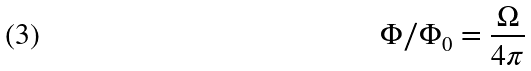Convert formula to latex. <formula><loc_0><loc_0><loc_500><loc_500>\Phi / \Phi _ { 0 } = \frac { \Omega } { 4 \pi }</formula> 